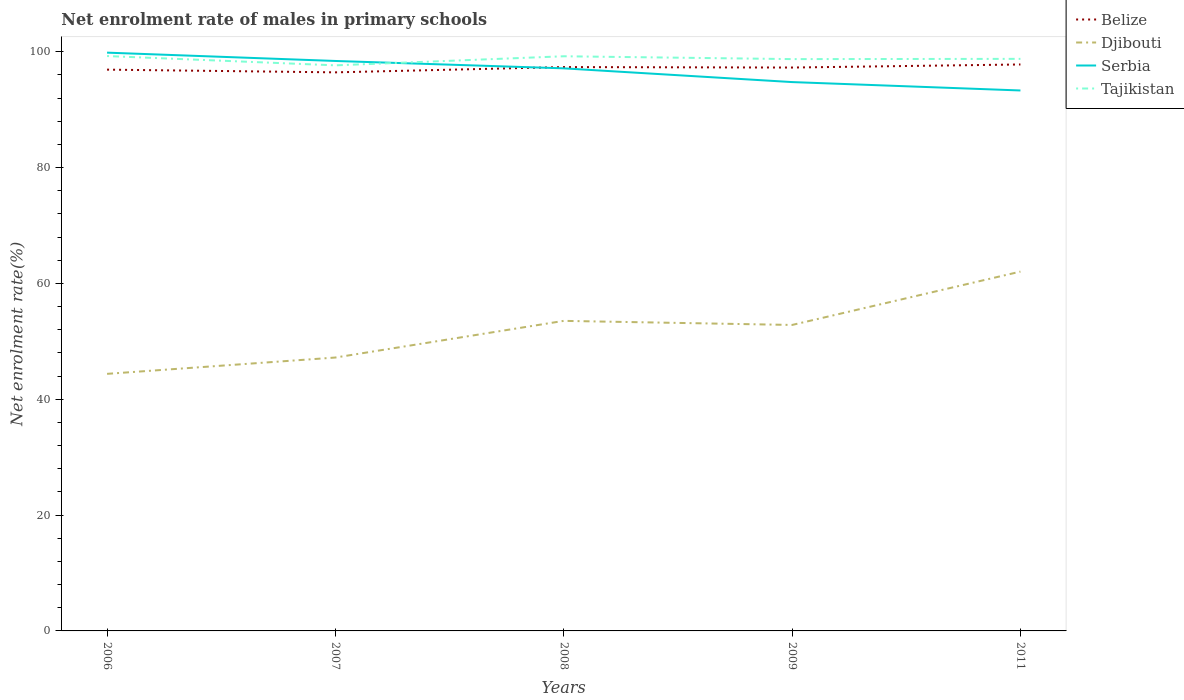How many different coloured lines are there?
Provide a succinct answer. 4. Across all years, what is the maximum net enrolment rate of males in primary schools in Djibouti?
Your answer should be very brief. 44.38. In which year was the net enrolment rate of males in primary schools in Tajikistan maximum?
Your answer should be very brief. 2007. What is the total net enrolment rate of males in primary schools in Djibouti in the graph?
Offer a terse response. -6.33. What is the difference between the highest and the second highest net enrolment rate of males in primary schools in Serbia?
Give a very brief answer. 6.53. What is the difference between the highest and the lowest net enrolment rate of males in primary schools in Djibouti?
Make the answer very short. 3. Is the net enrolment rate of males in primary schools in Tajikistan strictly greater than the net enrolment rate of males in primary schools in Serbia over the years?
Keep it short and to the point. No. How many lines are there?
Give a very brief answer. 4. What is the difference between two consecutive major ticks on the Y-axis?
Ensure brevity in your answer.  20. Are the values on the major ticks of Y-axis written in scientific E-notation?
Offer a terse response. No. Does the graph contain grids?
Give a very brief answer. No. Where does the legend appear in the graph?
Offer a very short reply. Top right. How many legend labels are there?
Offer a terse response. 4. How are the legend labels stacked?
Ensure brevity in your answer.  Vertical. What is the title of the graph?
Ensure brevity in your answer.  Net enrolment rate of males in primary schools. Does "Tanzania" appear as one of the legend labels in the graph?
Offer a terse response. No. What is the label or title of the Y-axis?
Give a very brief answer. Net enrolment rate(%). What is the Net enrolment rate(%) of Belize in 2006?
Give a very brief answer. 96.9. What is the Net enrolment rate(%) of Djibouti in 2006?
Make the answer very short. 44.38. What is the Net enrolment rate(%) of Serbia in 2006?
Your answer should be compact. 99.84. What is the Net enrolment rate(%) in Tajikistan in 2006?
Your response must be concise. 99.25. What is the Net enrolment rate(%) of Belize in 2007?
Ensure brevity in your answer.  96.43. What is the Net enrolment rate(%) in Djibouti in 2007?
Give a very brief answer. 47.2. What is the Net enrolment rate(%) in Serbia in 2007?
Your answer should be very brief. 98.4. What is the Net enrolment rate(%) of Tajikistan in 2007?
Make the answer very short. 97.64. What is the Net enrolment rate(%) in Belize in 2008?
Offer a terse response. 97.34. What is the Net enrolment rate(%) of Djibouti in 2008?
Make the answer very short. 53.53. What is the Net enrolment rate(%) of Serbia in 2008?
Give a very brief answer. 97.13. What is the Net enrolment rate(%) in Tajikistan in 2008?
Offer a very short reply. 99.21. What is the Net enrolment rate(%) of Belize in 2009?
Provide a succinct answer. 97.26. What is the Net enrolment rate(%) in Djibouti in 2009?
Provide a succinct answer. 52.82. What is the Net enrolment rate(%) of Serbia in 2009?
Your answer should be compact. 94.75. What is the Net enrolment rate(%) of Tajikistan in 2009?
Make the answer very short. 98.72. What is the Net enrolment rate(%) of Belize in 2011?
Keep it short and to the point. 97.79. What is the Net enrolment rate(%) in Djibouti in 2011?
Your answer should be compact. 62.04. What is the Net enrolment rate(%) in Serbia in 2011?
Offer a terse response. 93.3. What is the Net enrolment rate(%) in Tajikistan in 2011?
Give a very brief answer. 98.76. Across all years, what is the maximum Net enrolment rate(%) in Belize?
Make the answer very short. 97.79. Across all years, what is the maximum Net enrolment rate(%) of Djibouti?
Offer a terse response. 62.04. Across all years, what is the maximum Net enrolment rate(%) in Serbia?
Your answer should be very brief. 99.84. Across all years, what is the maximum Net enrolment rate(%) in Tajikistan?
Make the answer very short. 99.25. Across all years, what is the minimum Net enrolment rate(%) in Belize?
Make the answer very short. 96.43. Across all years, what is the minimum Net enrolment rate(%) of Djibouti?
Offer a very short reply. 44.38. Across all years, what is the minimum Net enrolment rate(%) in Serbia?
Ensure brevity in your answer.  93.3. Across all years, what is the minimum Net enrolment rate(%) in Tajikistan?
Offer a terse response. 97.64. What is the total Net enrolment rate(%) of Belize in the graph?
Your response must be concise. 485.73. What is the total Net enrolment rate(%) in Djibouti in the graph?
Make the answer very short. 259.97. What is the total Net enrolment rate(%) in Serbia in the graph?
Make the answer very short. 483.42. What is the total Net enrolment rate(%) in Tajikistan in the graph?
Your answer should be very brief. 493.58. What is the difference between the Net enrolment rate(%) in Belize in 2006 and that in 2007?
Give a very brief answer. 0.47. What is the difference between the Net enrolment rate(%) of Djibouti in 2006 and that in 2007?
Ensure brevity in your answer.  -2.82. What is the difference between the Net enrolment rate(%) in Serbia in 2006 and that in 2007?
Provide a short and direct response. 1.44. What is the difference between the Net enrolment rate(%) in Tajikistan in 2006 and that in 2007?
Ensure brevity in your answer.  1.61. What is the difference between the Net enrolment rate(%) in Belize in 2006 and that in 2008?
Make the answer very short. -0.44. What is the difference between the Net enrolment rate(%) in Djibouti in 2006 and that in 2008?
Give a very brief answer. -9.15. What is the difference between the Net enrolment rate(%) of Serbia in 2006 and that in 2008?
Make the answer very short. 2.71. What is the difference between the Net enrolment rate(%) of Tajikistan in 2006 and that in 2008?
Make the answer very short. 0.04. What is the difference between the Net enrolment rate(%) in Belize in 2006 and that in 2009?
Keep it short and to the point. -0.36. What is the difference between the Net enrolment rate(%) in Djibouti in 2006 and that in 2009?
Make the answer very short. -8.44. What is the difference between the Net enrolment rate(%) of Serbia in 2006 and that in 2009?
Provide a short and direct response. 5.08. What is the difference between the Net enrolment rate(%) of Tajikistan in 2006 and that in 2009?
Offer a terse response. 0.53. What is the difference between the Net enrolment rate(%) in Belize in 2006 and that in 2011?
Offer a very short reply. -0.89. What is the difference between the Net enrolment rate(%) of Djibouti in 2006 and that in 2011?
Give a very brief answer. -17.65. What is the difference between the Net enrolment rate(%) of Serbia in 2006 and that in 2011?
Give a very brief answer. 6.53. What is the difference between the Net enrolment rate(%) in Tajikistan in 2006 and that in 2011?
Offer a terse response. 0.49. What is the difference between the Net enrolment rate(%) of Belize in 2007 and that in 2008?
Your response must be concise. -0.91. What is the difference between the Net enrolment rate(%) in Djibouti in 2007 and that in 2008?
Provide a succinct answer. -6.33. What is the difference between the Net enrolment rate(%) of Serbia in 2007 and that in 2008?
Make the answer very short. 1.27. What is the difference between the Net enrolment rate(%) in Tajikistan in 2007 and that in 2008?
Provide a succinct answer. -1.57. What is the difference between the Net enrolment rate(%) of Belize in 2007 and that in 2009?
Provide a short and direct response. -0.83. What is the difference between the Net enrolment rate(%) of Djibouti in 2007 and that in 2009?
Ensure brevity in your answer.  -5.62. What is the difference between the Net enrolment rate(%) of Serbia in 2007 and that in 2009?
Offer a very short reply. 3.64. What is the difference between the Net enrolment rate(%) in Tajikistan in 2007 and that in 2009?
Make the answer very short. -1.08. What is the difference between the Net enrolment rate(%) in Belize in 2007 and that in 2011?
Provide a short and direct response. -1.36. What is the difference between the Net enrolment rate(%) in Djibouti in 2007 and that in 2011?
Provide a succinct answer. -14.84. What is the difference between the Net enrolment rate(%) in Serbia in 2007 and that in 2011?
Give a very brief answer. 5.09. What is the difference between the Net enrolment rate(%) of Tajikistan in 2007 and that in 2011?
Keep it short and to the point. -1.12. What is the difference between the Net enrolment rate(%) in Belize in 2008 and that in 2009?
Provide a short and direct response. 0.08. What is the difference between the Net enrolment rate(%) of Djibouti in 2008 and that in 2009?
Ensure brevity in your answer.  0.7. What is the difference between the Net enrolment rate(%) of Serbia in 2008 and that in 2009?
Offer a very short reply. 2.37. What is the difference between the Net enrolment rate(%) of Tajikistan in 2008 and that in 2009?
Ensure brevity in your answer.  0.49. What is the difference between the Net enrolment rate(%) of Belize in 2008 and that in 2011?
Ensure brevity in your answer.  -0.45. What is the difference between the Net enrolment rate(%) of Djibouti in 2008 and that in 2011?
Give a very brief answer. -8.51. What is the difference between the Net enrolment rate(%) in Serbia in 2008 and that in 2011?
Make the answer very short. 3.82. What is the difference between the Net enrolment rate(%) of Tajikistan in 2008 and that in 2011?
Make the answer very short. 0.45. What is the difference between the Net enrolment rate(%) in Belize in 2009 and that in 2011?
Your response must be concise. -0.53. What is the difference between the Net enrolment rate(%) of Djibouti in 2009 and that in 2011?
Provide a succinct answer. -9.21. What is the difference between the Net enrolment rate(%) in Serbia in 2009 and that in 2011?
Give a very brief answer. 1.45. What is the difference between the Net enrolment rate(%) in Tajikistan in 2009 and that in 2011?
Ensure brevity in your answer.  -0.04. What is the difference between the Net enrolment rate(%) in Belize in 2006 and the Net enrolment rate(%) in Djibouti in 2007?
Provide a succinct answer. 49.7. What is the difference between the Net enrolment rate(%) in Belize in 2006 and the Net enrolment rate(%) in Serbia in 2007?
Your answer should be compact. -1.5. What is the difference between the Net enrolment rate(%) in Belize in 2006 and the Net enrolment rate(%) in Tajikistan in 2007?
Give a very brief answer. -0.74. What is the difference between the Net enrolment rate(%) in Djibouti in 2006 and the Net enrolment rate(%) in Serbia in 2007?
Provide a short and direct response. -54.02. What is the difference between the Net enrolment rate(%) of Djibouti in 2006 and the Net enrolment rate(%) of Tajikistan in 2007?
Keep it short and to the point. -53.26. What is the difference between the Net enrolment rate(%) of Serbia in 2006 and the Net enrolment rate(%) of Tajikistan in 2007?
Give a very brief answer. 2.2. What is the difference between the Net enrolment rate(%) of Belize in 2006 and the Net enrolment rate(%) of Djibouti in 2008?
Give a very brief answer. 43.37. What is the difference between the Net enrolment rate(%) of Belize in 2006 and the Net enrolment rate(%) of Serbia in 2008?
Provide a succinct answer. -0.23. What is the difference between the Net enrolment rate(%) in Belize in 2006 and the Net enrolment rate(%) in Tajikistan in 2008?
Your answer should be compact. -2.31. What is the difference between the Net enrolment rate(%) of Djibouti in 2006 and the Net enrolment rate(%) of Serbia in 2008?
Keep it short and to the point. -52.74. What is the difference between the Net enrolment rate(%) of Djibouti in 2006 and the Net enrolment rate(%) of Tajikistan in 2008?
Provide a short and direct response. -54.83. What is the difference between the Net enrolment rate(%) in Serbia in 2006 and the Net enrolment rate(%) in Tajikistan in 2008?
Offer a terse response. 0.63. What is the difference between the Net enrolment rate(%) in Belize in 2006 and the Net enrolment rate(%) in Djibouti in 2009?
Ensure brevity in your answer.  44.08. What is the difference between the Net enrolment rate(%) in Belize in 2006 and the Net enrolment rate(%) in Serbia in 2009?
Offer a terse response. 2.15. What is the difference between the Net enrolment rate(%) in Belize in 2006 and the Net enrolment rate(%) in Tajikistan in 2009?
Offer a terse response. -1.82. What is the difference between the Net enrolment rate(%) in Djibouti in 2006 and the Net enrolment rate(%) in Serbia in 2009?
Keep it short and to the point. -50.37. What is the difference between the Net enrolment rate(%) of Djibouti in 2006 and the Net enrolment rate(%) of Tajikistan in 2009?
Give a very brief answer. -54.34. What is the difference between the Net enrolment rate(%) in Serbia in 2006 and the Net enrolment rate(%) in Tajikistan in 2009?
Provide a succinct answer. 1.12. What is the difference between the Net enrolment rate(%) of Belize in 2006 and the Net enrolment rate(%) of Djibouti in 2011?
Your response must be concise. 34.86. What is the difference between the Net enrolment rate(%) in Belize in 2006 and the Net enrolment rate(%) in Serbia in 2011?
Make the answer very short. 3.6. What is the difference between the Net enrolment rate(%) of Belize in 2006 and the Net enrolment rate(%) of Tajikistan in 2011?
Ensure brevity in your answer.  -1.86. What is the difference between the Net enrolment rate(%) of Djibouti in 2006 and the Net enrolment rate(%) of Serbia in 2011?
Your response must be concise. -48.92. What is the difference between the Net enrolment rate(%) of Djibouti in 2006 and the Net enrolment rate(%) of Tajikistan in 2011?
Offer a terse response. -54.38. What is the difference between the Net enrolment rate(%) in Serbia in 2006 and the Net enrolment rate(%) in Tajikistan in 2011?
Offer a very short reply. 1.07. What is the difference between the Net enrolment rate(%) in Belize in 2007 and the Net enrolment rate(%) in Djibouti in 2008?
Provide a succinct answer. 42.9. What is the difference between the Net enrolment rate(%) of Belize in 2007 and the Net enrolment rate(%) of Serbia in 2008?
Ensure brevity in your answer.  -0.69. What is the difference between the Net enrolment rate(%) in Belize in 2007 and the Net enrolment rate(%) in Tajikistan in 2008?
Your response must be concise. -2.78. What is the difference between the Net enrolment rate(%) in Djibouti in 2007 and the Net enrolment rate(%) in Serbia in 2008?
Offer a terse response. -49.93. What is the difference between the Net enrolment rate(%) of Djibouti in 2007 and the Net enrolment rate(%) of Tajikistan in 2008?
Your answer should be very brief. -52.01. What is the difference between the Net enrolment rate(%) in Serbia in 2007 and the Net enrolment rate(%) in Tajikistan in 2008?
Your response must be concise. -0.81. What is the difference between the Net enrolment rate(%) of Belize in 2007 and the Net enrolment rate(%) of Djibouti in 2009?
Provide a short and direct response. 43.61. What is the difference between the Net enrolment rate(%) of Belize in 2007 and the Net enrolment rate(%) of Serbia in 2009?
Keep it short and to the point. 1.68. What is the difference between the Net enrolment rate(%) in Belize in 2007 and the Net enrolment rate(%) in Tajikistan in 2009?
Ensure brevity in your answer.  -2.29. What is the difference between the Net enrolment rate(%) of Djibouti in 2007 and the Net enrolment rate(%) of Serbia in 2009?
Make the answer very short. -47.55. What is the difference between the Net enrolment rate(%) of Djibouti in 2007 and the Net enrolment rate(%) of Tajikistan in 2009?
Your answer should be very brief. -51.52. What is the difference between the Net enrolment rate(%) of Serbia in 2007 and the Net enrolment rate(%) of Tajikistan in 2009?
Give a very brief answer. -0.32. What is the difference between the Net enrolment rate(%) of Belize in 2007 and the Net enrolment rate(%) of Djibouti in 2011?
Your answer should be compact. 34.4. What is the difference between the Net enrolment rate(%) of Belize in 2007 and the Net enrolment rate(%) of Serbia in 2011?
Offer a terse response. 3.13. What is the difference between the Net enrolment rate(%) of Belize in 2007 and the Net enrolment rate(%) of Tajikistan in 2011?
Offer a terse response. -2.33. What is the difference between the Net enrolment rate(%) of Djibouti in 2007 and the Net enrolment rate(%) of Serbia in 2011?
Offer a terse response. -46.1. What is the difference between the Net enrolment rate(%) in Djibouti in 2007 and the Net enrolment rate(%) in Tajikistan in 2011?
Provide a succinct answer. -51.56. What is the difference between the Net enrolment rate(%) of Serbia in 2007 and the Net enrolment rate(%) of Tajikistan in 2011?
Provide a short and direct response. -0.36. What is the difference between the Net enrolment rate(%) of Belize in 2008 and the Net enrolment rate(%) of Djibouti in 2009?
Your answer should be very brief. 44.52. What is the difference between the Net enrolment rate(%) of Belize in 2008 and the Net enrolment rate(%) of Serbia in 2009?
Provide a short and direct response. 2.59. What is the difference between the Net enrolment rate(%) of Belize in 2008 and the Net enrolment rate(%) of Tajikistan in 2009?
Your response must be concise. -1.38. What is the difference between the Net enrolment rate(%) of Djibouti in 2008 and the Net enrolment rate(%) of Serbia in 2009?
Your response must be concise. -41.23. What is the difference between the Net enrolment rate(%) in Djibouti in 2008 and the Net enrolment rate(%) in Tajikistan in 2009?
Keep it short and to the point. -45.19. What is the difference between the Net enrolment rate(%) in Serbia in 2008 and the Net enrolment rate(%) in Tajikistan in 2009?
Your response must be concise. -1.59. What is the difference between the Net enrolment rate(%) of Belize in 2008 and the Net enrolment rate(%) of Djibouti in 2011?
Give a very brief answer. 35.31. What is the difference between the Net enrolment rate(%) in Belize in 2008 and the Net enrolment rate(%) in Serbia in 2011?
Make the answer very short. 4.04. What is the difference between the Net enrolment rate(%) in Belize in 2008 and the Net enrolment rate(%) in Tajikistan in 2011?
Provide a short and direct response. -1.42. What is the difference between the Net enrolment rate(%) in Djibouti in 2008 and the Net enrolment rate(%) in Serbia in 2011?
Ensure brevity in your answer.  -39.78. What is the difference between the Net enrolment rate(%) of Djibouti in 2008 and the Net enrolment rate(%) of Tajikistan in 2011?
Offer a very short reply. -45.23. What is the difference between the Net enrolment rate(%) of Serbia in 2008 and the Net enrolment rate(%) of Tajikistan in 2011?
Your answer should be compact. -1.64. What is the difference between the Net enrolment rate(%) of Belize in 2009 and the Net enrolment rate(%) of Djibouti in 2011?
Provide a short and direct response. 35.23. What is the difference between the Net enrolment rate(%) of Belize in 2009 and the Net enrolment rate(%) of Serbia in 2011?
Provide a succinct answer. 3.96. What is the difference between the Net enrolment rate(%) in Belize in 2009 and the Net enrolment rate(%) in Tajikistan in 2011?
Provide a short and direct response. -1.5. What is the difference between the Net enrolment rate(%) in Djibouti in 2009 and the Net enrolment rate(%) in Serbia in 2011?
Your response must be concise. -40.48. What is the difference between the Net enrolment rate(%) of Djibouti in 2009 and the Net enrolment rate(%) of Tajikistan in 2011?
Ensure brevity in your answer.  -45.94. What is the difference between the Net enrolment rate(%) of Serbia in 2009 and the Net enrolment rate(%) of Tajikistan in 2011?
Provide a succinct answer. -4.01. What is the average Net enrolment rate(%) in Belize per year?
Your answer should be compact. 97.15. What is the average Net enrolment rate(%) of Djibouti per year?
Make the answer very short. 51.99. What is the average Net enrolment rate(%) of Serbia per year?
Provide a short and direct response. 96.68. What is the average Net enrolment rate(%) in Tajikistan per year?
Offer a terse response. 98.72. In the year 2006, what is the difference between the Net enrolment rate(%) of Belize and Net enrolment rate(%) of Djibouti?
Ensure brevity in your answer.  52.52. In the year 2006, what is the difference between the Net enrolment rate(%) of Belize and Net enrolment rate(%) of Serbia?
Give a very brief answer. -2.94. In the year 2006, what is the difference between the Net enrolment rate(%) in Belize and Net enrolment rate(%) in Tajikistan?
Provide a short and direct response. -2.35. In the year 2006, what is the difference between the Net enrolment rate(%) of Djibouti and Net enrolment rate(%) of Serbia?
Offer a terse response. -55.46. In the year 2006, what is the difference between the Net enrolment rate(%) of Djibouti and Net enrolment rate(%) of Tajikistan?
Offer a terse response. -54.87. In the year 2006, what is the difference between the Net enrolment rate(%) of Serbia and Net enrolment rate(%) of Tajikistan?
Offer a terse response. 0.59. In the year 2007, what is the difference between the Net enrolment rate(%) in Belize and Net enrolment rate(%) in Djibouti?
Offer a very short reply. 49.23. In the year 2007, what is the difference between the Net enrolment rate(%) in Belize and Net enrolment rate(%) in Serbia?
Offer a terse response. -1.96. In the year 2007, what is the difference between the Net enrolment rate(%) of Belize and Net enrolment rate(%) of Tajikistan?
Ensure brevity in your answer.  -1.21. In the year 2007, what is the difference between the Net enrolment rate(%) of Djibouti and Net enrolment rate(%) of Serbia?
Give a very brief answer. -51.2. In the year 2007, what is the difference between the Net enrolment rate(%) of Djibouti and Net enrolment rate(%) of Tajikistan?
Provide a short and direct response. -50.44. In the year 2007, what is the difference between the Net enrolment rate(%) of Serbia and Net enrolment rate(%) of Tajikistan?
Make the answer very short. 0.76. In the year 2008, what is the difference between the Net enrolment rate(%) in Belize and Net enrolment rate(%) in Djibouti?
Offer a very short reply. 43.82. In the year 2008, what is the difference between the Net enrolment rate(%) of Belize and Net enrolment rate(%) of Serbia?
Your response must be concise. 0.22. In the year 2008, what is the difference between the Net enrolment rate(%) in Belize and Net enrolment rate(%) in Tajikistan?
Provide a short and direct response. -1.87. In the year 2008, what is the difference between the Net enrolment rate(%) in Djibouti and Net enrolment rate(%) in Serbia?
Make the answer very short. -43.6. In the year 2008, what is the difference between the Net enrolment rate(%) in Djibouti and Net enrolment rate(%) in Tajikistan?
Offer a very short reply. -45.68. In the year 2008, what is the difference between the Net enrolment rate(%) of Serbia and Net enrolment rate(%) of Tajikistan?
Keep it short and to the point. -2.08. In the year 2009, what is the difference between the Net enrolment rate(%) of Belize and Net enrolment rate(%) of Djibouti?
Your answer should be very brief. 44.44. In the year 2009, what is the difference between the Net enrolment rate(%) of Belize and Net enrolment rate(%) of Serbia?
Offer a very short reply. 2.51. In the year 2009, what is the difference between the Net enrolment rate(%) in Belize and Net enrolment rate(%) in Tajikistan?
Your response must be concise. -1.46. In the year 2009, what is the difference between the Net enrolment rate(%) in Djibouti and Net enrolment rate(%) in Serbia?
Provide a short and direct response. -41.93. In the year 2009, what is the difference between the Net enrolment rate(%) in Djibouti and Net enrolment rate(%) in Tajikistan?
Keep it short and to the point. -45.9. In the year 2009, what is the difference between the Net enrolment rate(%) in Serbia and Net enrolment rate(%) in Tajikistan?
Ensure brevity in your answer.  -3.97. In the year 2011, what is the difference between the Net enrolment rate(%) in Belize and Net enrolment rate(%) in Djibouti?
Your answer should be very brief. 35.76. In the year 2011, what is the difference between the Net enrolment rate(%) of Belize and Net enrolment rate(%) of Serbia?
Your response must be concise. 4.49. In the year 2011, what is the difference between the Net enrolment rate(%) in Belize and Net enrolment rate(%) in Tajikistan?
Keep it short and to the point. -0.97. In the year 2011, what is the difference between the Net enrolment rate(%) in Djibouti and Net enrolment rate(%) in Serbia?
Offer a terse response. -31.27. In the year 2011, what is the difference between the Net enrolment rate(%) of Djibouti and Net enrolment rate(%) of Tajikistan?
Your answer should be very brief. -36.73. In the year 2011, what is the difference between the Net enrolment rate(%) in Serbia and Net enrolment rate(%) in Tajikistan?
Your answer should be compact. -5.46. What is the ratio of the Net enrolment rate(%) in Djibouti in 2006 to that in 2007?
Provide a succinct answer. 0.94. What is the ratio of the Net enrolment rate(%) in Serbia in 2006 to that in 2007?
Give a very brief answer. 1.01. What is the ratio of the Net enrolment rate(%) in Tajikistan in 2006 to that in 2007?
Give a very brief answer. 1.02. What is the ratio of the Net enrolment rate(%) of Djibouti in 2006 to that in 2008?
Give a very brief answer. 0.83. What is the ratio of the Net enrolment rate(%) in Serbia in 2006 to that in 2008?
Make the answer very short. 1.03. What is the ratio of the Net enrolment rate(%) in Tajikistan in 2006 to that in 2008?
Provide a succinct answer. 1. What is the ratio of the Net enrolment rate(%) of Djibouti in 2006 to that in 2009?
Provide a succinct answer. 0.84. What is the ratio of the Net enrolment rate(%) of Serbia in 2006 to that in 2009?
Offer a very short reply. 1.05. What is the ratio of the Net enrolment rate(%) in Tajikistan in 2006 to that in 2009?
Your answer should be compact. 1.01. What is the ratio of the Net enrolment rate(%) in Belize in 2006 to that in 2011?
Keep it short and to the point. 0.99. What is the ratio of the Net enrolment rate(%) in Djibouti in 2006 to that in 2011?
Offer a very short reply. 0.72. What is the ratio of the Net enrolment rate(%) in Serbia in 2006 to that in 2011?
Provide a short and direct response. 1.07. What is the ratio of the Net enrolment rate(%) in Tajikistan in 2006 to that in 2011?
Your response must be concise. 1. What is the ratio of the Net enrolment rate(%) of Belize in 2007 to that in 2008?
Offer a very short reply. 0.99. What is the ratio of the Net enrolment rate(%) of Djibouti in 2007 to that in 2008?
Keep it short and to the point. 0.88. What is the ratio of the Net enrolment rate(%) in Serbia in 2007 to that in 2008?
Ensure brevity in your answer.  1.01. What is the ratio of the Net enrolment rate(%) of Tajikistan in 2007 to that in 2008?
Your answer should be very brief. 0.98. What is the ratio of the Net enrolment rate(%) in Djibouti in 2007 to that in 2009?
Your answer should be compact. 0.89. What is the ratio of the Net enrolment rate(%) of Serbia in 2007 to that in 2009?
Ensure brevity in your answer.  1.04. What is the ratio of the Net enrolment rate(%) of Belize in 2007 to that in 2011?
Give a very brief answer. 0.99. What is the ratio of the Net enrolment rate(%) of Djibouti in 2007 to that in 2011?
Provide a succinct answer. 0.76. What is the ratio of the Net enrolment rate(%) of Serbia in 2007 to that in 2011?
Ensure brevity in your answer.  1.05. What is the ratio of the Net enrolment rate(%) of Tajikistan in 2007 to that in 2011?
Provide a succinct answer. 0.99. What is the ratio of the Net enrolment rate(%) of Djibouti in 2008 to that in 2009?
Your answer should be compact. 1.01. What is the ratio of the Net enrolment rate(%) of Serbia in 2008 to that in 2009?
Provide a short and direct response. 1.02. What is the ratio of the Net enrolment rate(%) in Tajikistan in 2008 to that in 2009?
Ensure brevity in your answer.  1. What is the ratio of the Net enrolment rate(%) in Djibouti in 2008 to that in 2011?
Give a very brief answer. 0.86. What is the ratio of the Net enrolment rate(%) in Serbia in 2008 to that in 2011?
Your answer should be very brief. 1.04. What is the ratio of the Net enrolment rate(%) in Belize in 2009 to that in 2011?
Your response must be concise. 0.99. What is the ratio of the Net enrolment rate(%) in Djibouti in 2009 to that in 2011?
Provide a succinct answer. 0.85. What is the ratio of the Net enrolment rate(%) in Serbia in 2009 to that in 2011?
Give a very brief answer. 1.02. What is the ratio of the Net enrolment rate(%) of Tajikistan in 2009 to that in 2011?
Offer a very short reply. 1. What is the difference between the highest and the second highest Net enrolment rate(%) of Belize?
Give a very brief answer. 0.45. What is the difference between the highest and the second highest Net enrolment rate(%) of Djibouti?
Provide a short and direct response. 8.51. What is the difference between the highest and the second highest Net enrolment rate(%) of Serbia?
Provide a succinct answer. 1.44. What is the difference between the highest and the second highest Net enrolment rate(%) of Tajikistan?
Offer a terse response. 0.04. What is the difference between the highest and the lowest Net enrolment rate(%) of Belize?
Make the answer very short. 1.36. What is the difference between the highest and the lowest Net enrolment rate(%) of Djibouti?
Your answer should be very brief. 17.65. What is the difference between the highest and the lowest Net enrolment rate(%) in Serbia?
Offer a very short reply. 6.53. What is the difference between the highest and the lowest Net enrolment rate(%) of Tajikistan?
Provide a short and direct response. 1.61. 